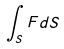<formula> <loc_0><loc_0><loc_500><loc_500>\int _ { S } F d S</formula> 